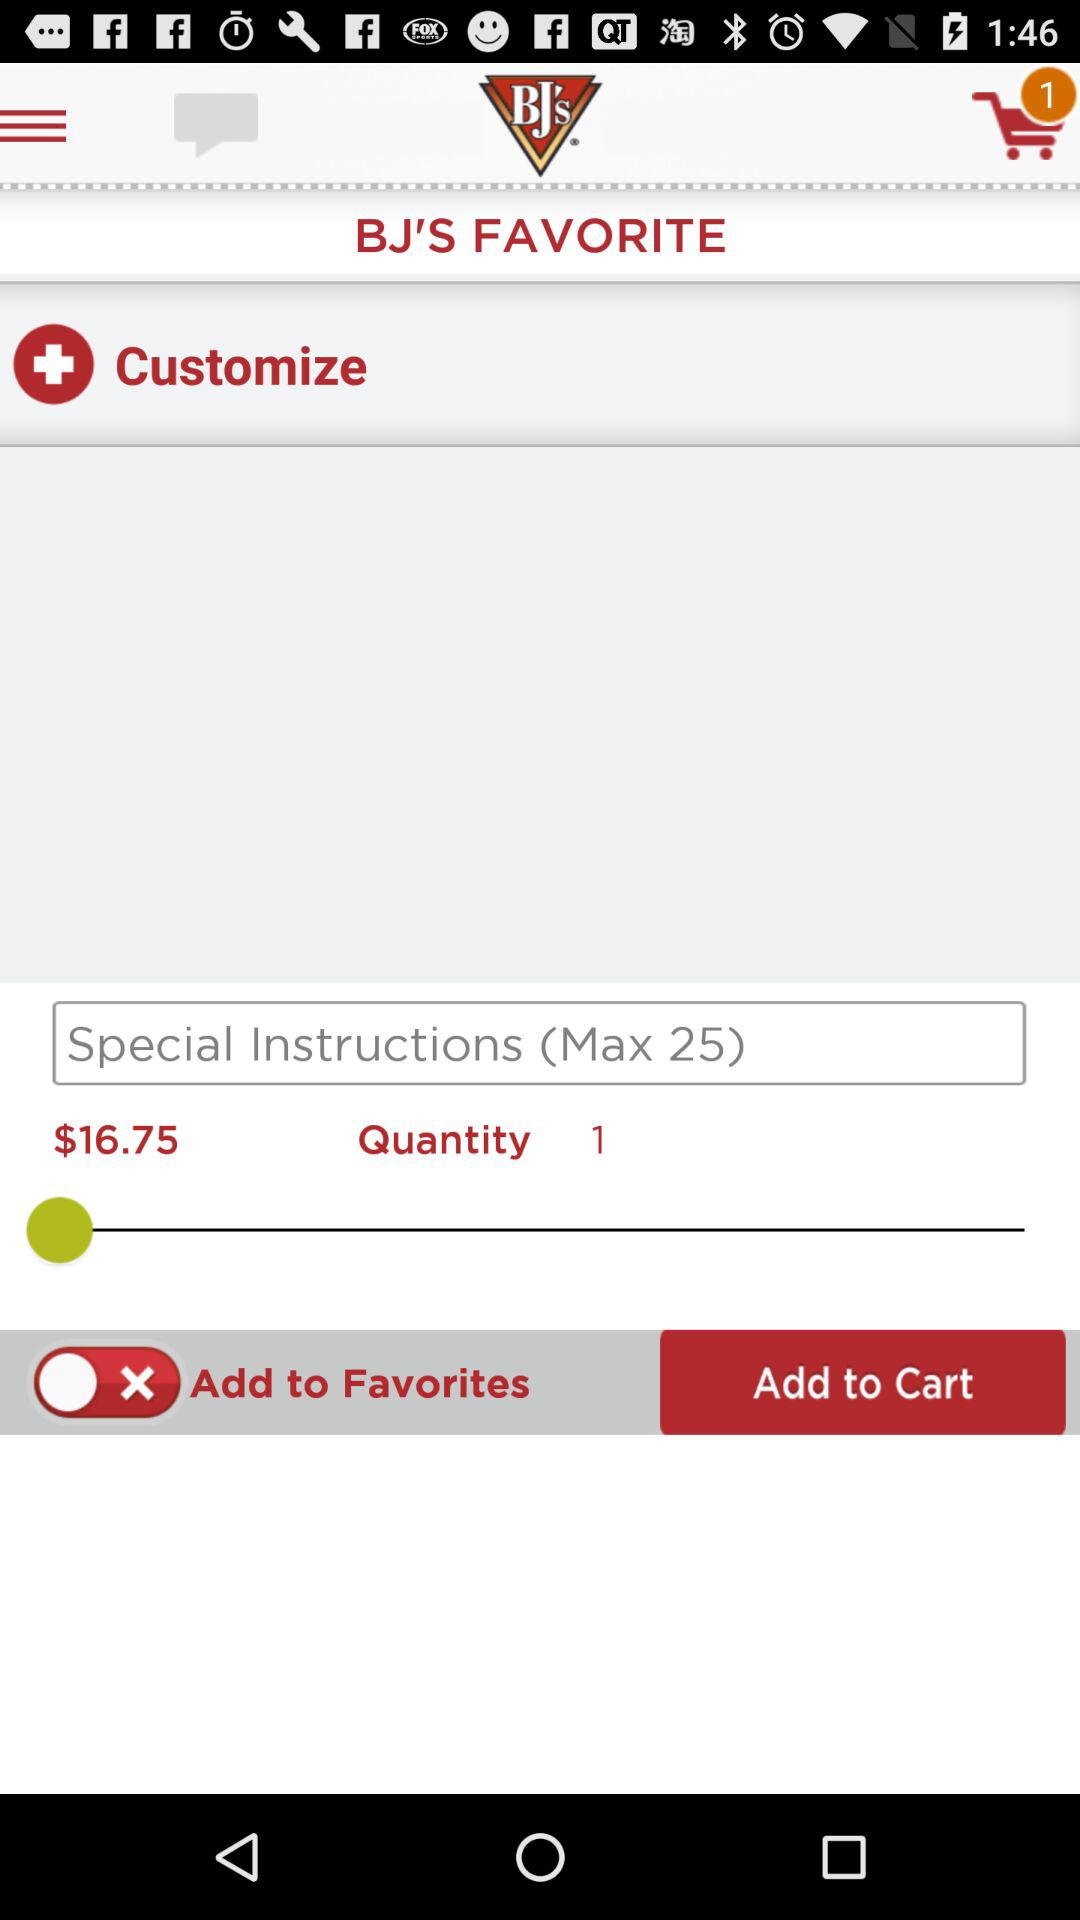What is the shown price? The shown price is $16.75. 